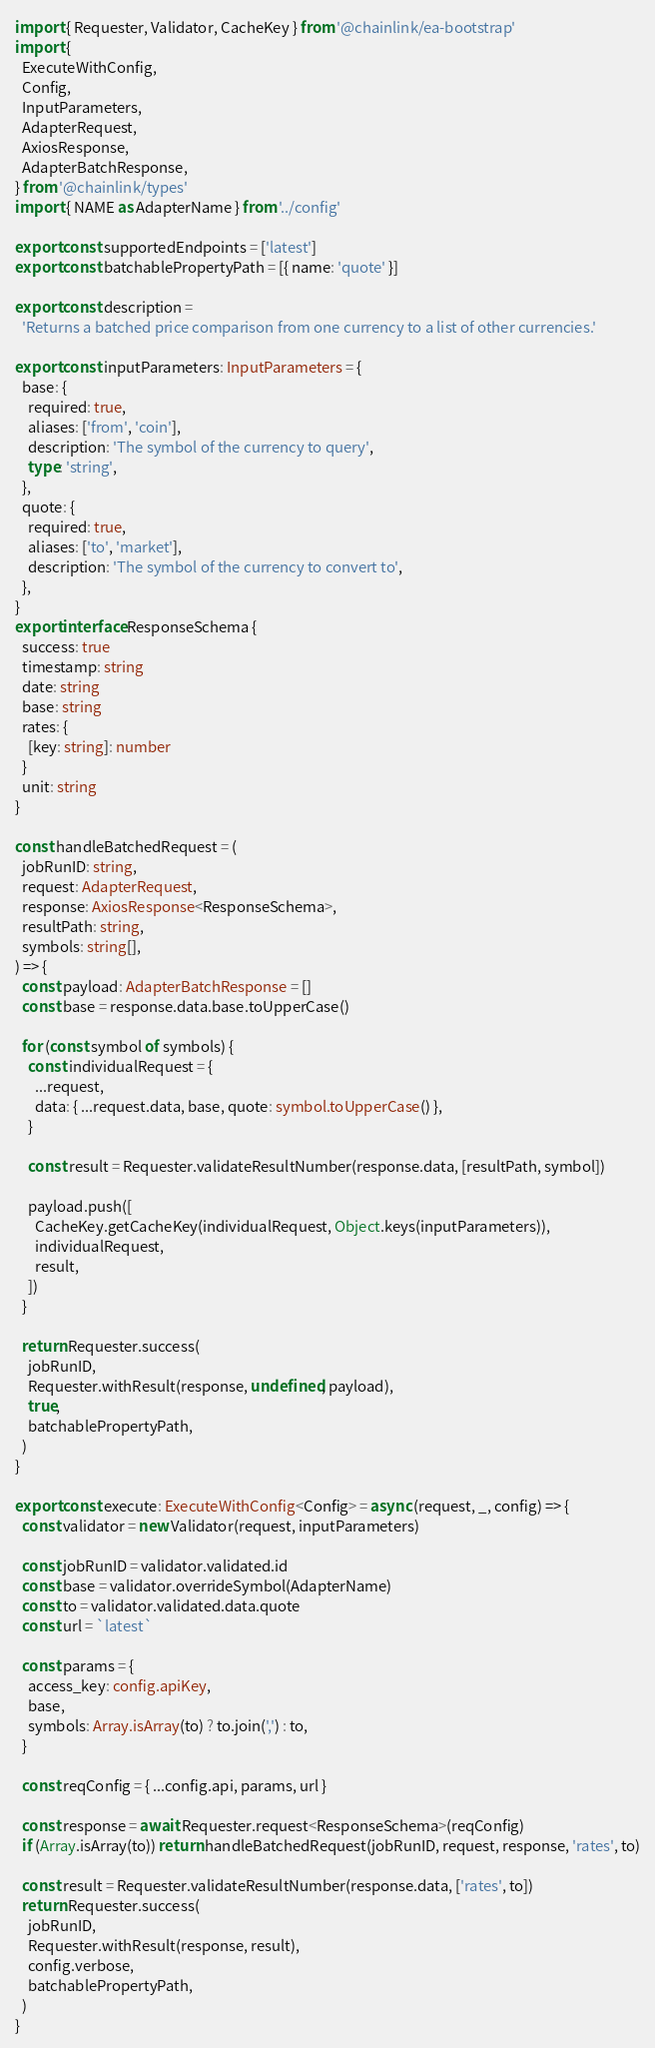Convert code to text. <code><loc_0><loc_0><loc_500><loc_500><_TypeScript_>import { Requester, Validator, CacheKey } from '@chainlink/ea-bootstrap'
import {
  ExecuteWithConfig,
  Config,
  InputParameters,
  AdapterRequest,
  AxiosResponse,
  AdapterBatchResponse,
} from '@chainlink/types'
import { NAME as AdapterName } from '../config'

export const supportedEndpoints = ['latest']
export const batchablePropertyPath = [{ name: 'quote' }]

export const description =
  'Returns a batched price comparison from one currency to a list of other currencies.'

export const inputParameters: InputParameters = {
  base: {
    required: true,
    aliases: ['from', 'coin'],
    description: 'The symbol of the currency to query',
    type: 'string',
  },
  quote: {
    required: true,
    aliases: ['to', 'market'],
    description: 'The symbol of the currency to convert to',
  },
}
export interface ResponseSchema {
  success: true
  timestamp: string
  date: string
  base: string
  rates: {
    [key: string]: number
  }
  unit: string
}

const handleBatchedRequest = (
  jobRunID: string,
  request: AdapterRequest,
  response: AxiosResponse<ResponseSchema>,
  resultPath: string,
  symbols: string[],
) => {
  const payload: AdapterBatchResponse = []
  const base = response.data.base.toUpperCase()

  for (const symbol of symbols) {
    const individualRequest = {
      ...request,
      data: { ...request.data, base, quote: symbol.toUpperCase() },
    }

    const result = Requester.validateResultNumber(response.data, [resultPath, symbol])

    payload.push([
      CacheKey.getCacheKey(individualRequest, Object.keys(inputParameters)),
      individualRequest,
      result,
    ])
  }

  return Requester.success(
    jobRunID,
    Requester.withResult(response, undefined, payload),
    true,
    batchablePropertyPath,
  )
}

export const execute: ExecuteWithConfig<Config> = async (request, _, config) => {
  const validator = new Validator(request, inputParameters)

  const jobRunID = validator.validated.id
  const base = validator.overrideSymbol(AdapterName)
  const to = validator.validated.data.quote
  const url = `latest`

  const params = {
    access_key: config.apiKey,
    base,
    symbols: Array.isArray(to) ? to.join(',') : to,
  }

  const reqConfig = { ...config.api, params, url }

  const response = await Requester.request<ResponseSchema>(reqConfig)
  if (Array.isArray(to)) return handleBatchedRequest(jobRunID, request, response, 'rates', to)

  const result = Requester.validateResultNumber(response.data, ['rates', to])
  return Requester.success(
    jobRunID,
    Requester.withResult(response, result),
    config.verbose,
    batchablePropertyPath,
  )
}
</code> 